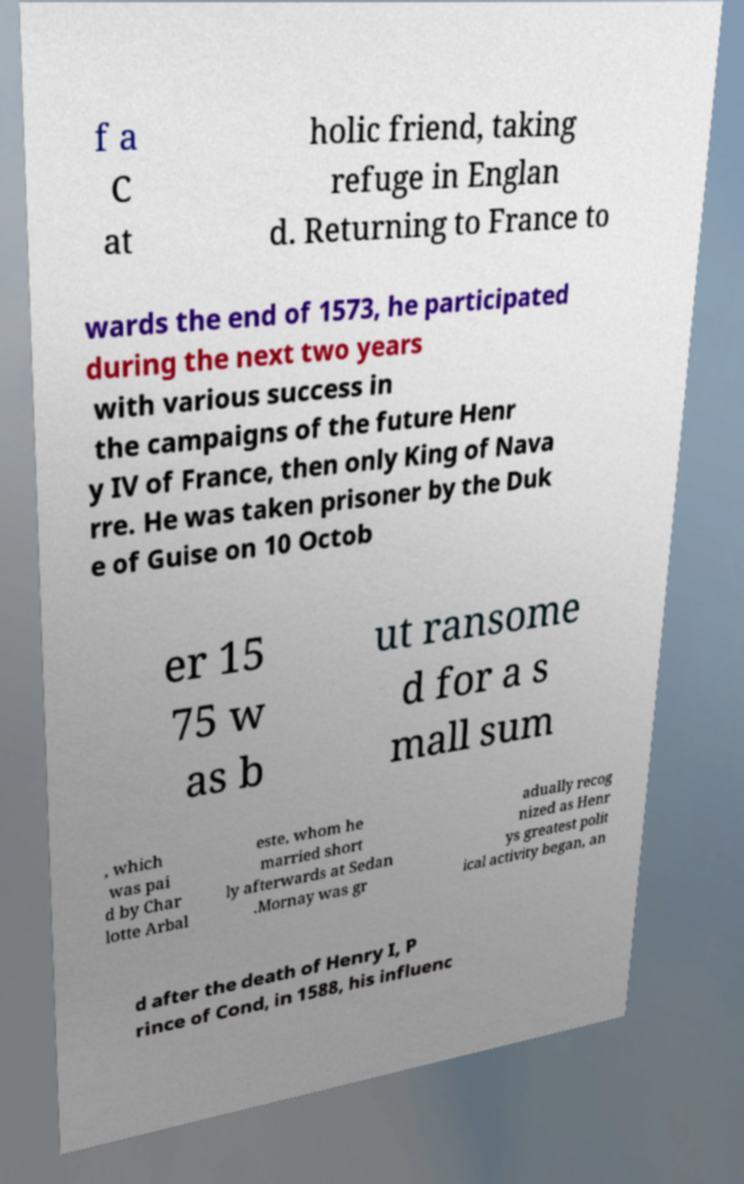Can you accurately transcribe the text from the provided image for me? f a C at holic friend, taking refuge in Englan d. Returning to France to wards the end of 1573, he participated during the next two years with various success in the campaigns of the future Henr y IV of France, then only King of Nava rre. He was taken prisoner by the Duk e of Guise on 10 Octob er 15 75 w as b ut ransome d for a s mall sum , which was pai d by Char lotte Arbal este, whom he married short ly afterwards at Sedan .Mornay was gr adually recog nized as Henr ys greatest polit ical activity began, an d after the death of Henry I, P rince of Cond, in 1588, his influenc 